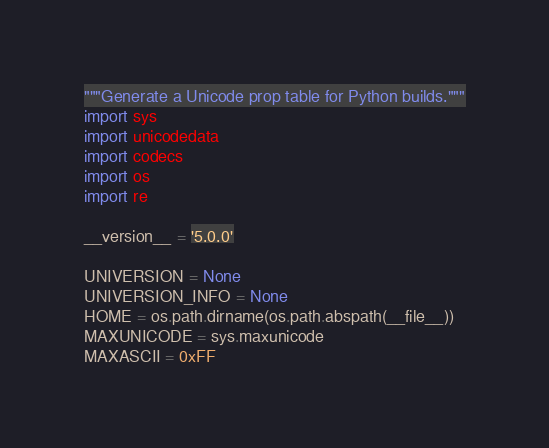<code> <loc_0><loc_0><loc_500><loc_500><_Python_>"""Generate a Unicode prop table for Python builds."""
import sys
import unicodedata
import codecs
import os
import re

__version__ = '5.0.0'

UNIVERSION = None
UNIVERSION_INFO = None
HOME = os.path.dirname(os.path.abspath(__file__))
MAXUNICODE = sys.maxunicode
MAXASCII = 0xFF</code> 